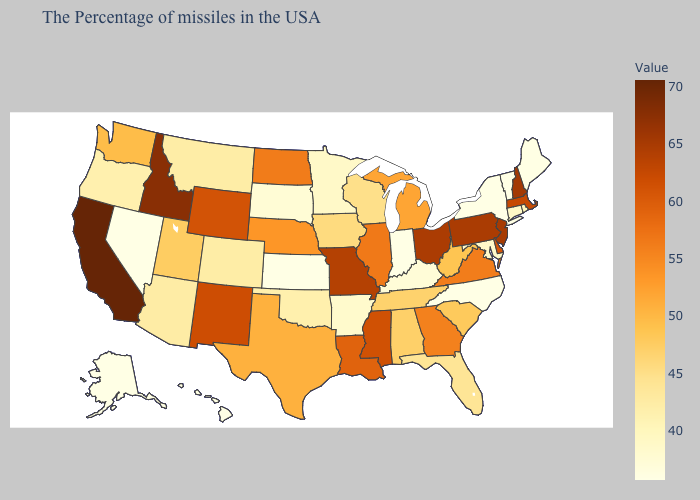Does Missouri have the highest value in the USA?
Quick response, please. No. Which states have the highest value in the USA?
Give a very brief answer. California. Does Arizona have a lower value than Alabama?
Write a very short answer. Yes. Which states hav the highest value in the MidWest?
Write a very short answer. Ohio. Which states have the lowest value in the USA?
Give a very brief answer. Vermont, New York, North Carolina, Indiana, Kansas, Nevada, Alaska, Hawaii. Is the legend a continuous bar?
Short answer required. Yes. Among the states that border Maine , which have the highest value?
Give a very brief answer. New Hampshire. Does Pennsylvania have the highest value in the Northeast?
Write a very short answer. No. 